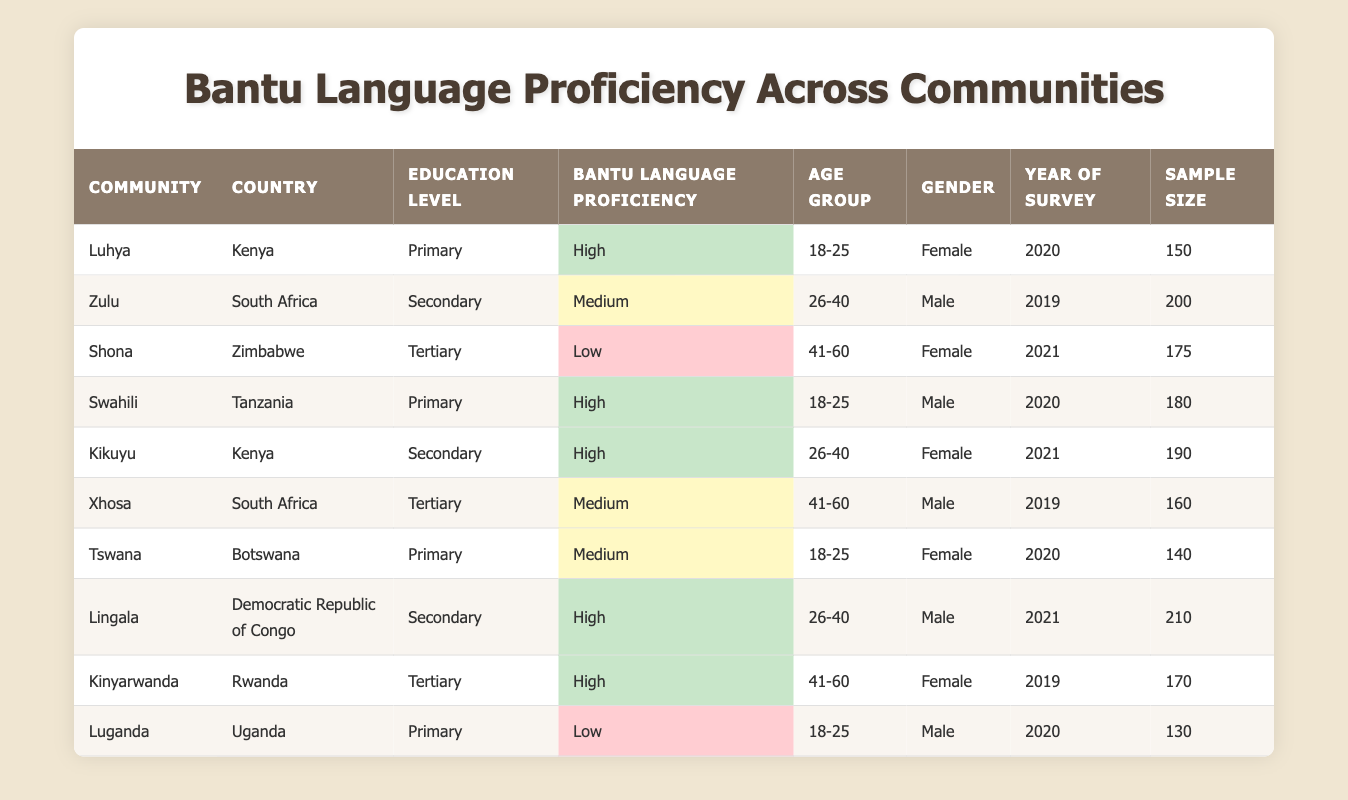What is the education level of the Kikuyu community? The Kikuyu community is listed under the "Education Level" column, where they are specified as "Secondary." This can be directly found in the table by locating the row corresponding to the Kikuyu community.
Answer: Secondary How many communities have high Bantu language proficiency? The "Bantu Language Proficiency" column can be examined to see which entries are marked as "High." There are four such communities: Luhya, Swahili, Kikuyu, and Lingala. Therefore, the total count is 4.
Answer: 4 What is the average sample size for respondents aged 18-25? The sample sizes for communities in the 18-25 age group are: Luhya (150), Swahili (180), Tswana (140), and Luganda (130). To find the average, we sum these sample sizes (150 + 180 + 140 + 130 = 600) and divide by the number of communities (4), giving us an average of 600/4 = 150.
Answer: 150 Is it true that there are any communities with tertiary education that have low Bantu language proficiency? Referring to the table, we can identify the communities with tertiary education: Shona, Xhosa, and Kinyarwanda. Only the Shona community has a "Low" proficiency, while the others have "Medium" and "High." Thus, the statement is true.
Answer: Yes Which age group has the highest number of respondents among those with high Bantu language proficiency? To determine this, we examine the age groups associated with the communities having high proficiency: Luhya and Swahili (18-25), Kikuyu (26-40), and Lingala (26-40). Summing the sample sizes gives us: Luhya (150) + Swahili (180) = 330 for 18-25, and Kikuyu (190) + Lingala (210) = 400 for 26-40. Therefore, the age group 26-40 has the highest total of 400 respondents.
Answer: 26-40 